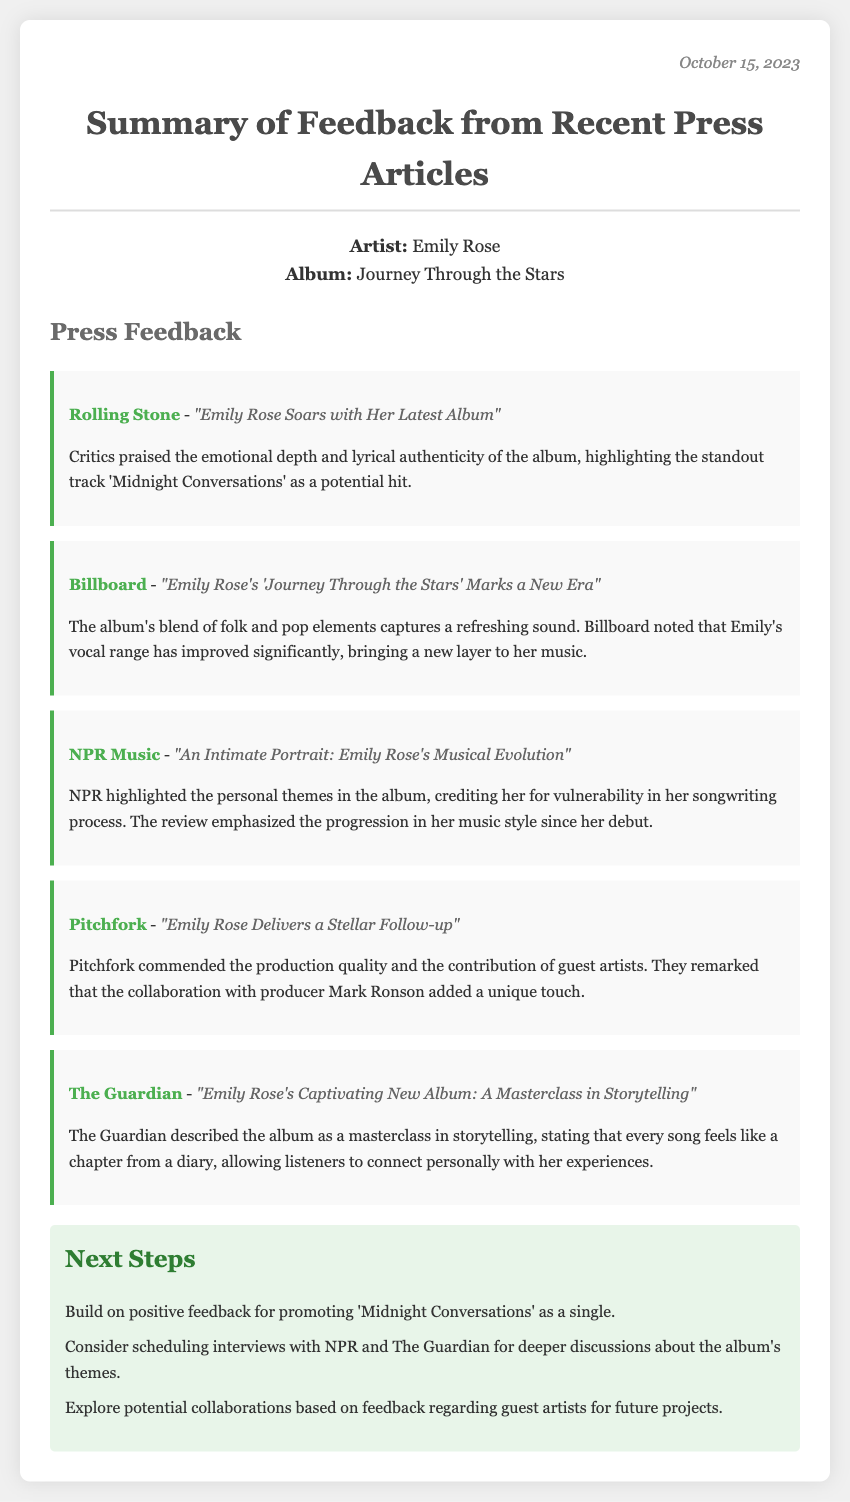What is the artist's name? The artist's name is mentioned in the album info section of the document.
Answer: Emily Rose What is the title of the album? The album title is stated right next to the artist's name in the album info section.
Answer: Journey Through the Stars Which publication praised the track 'Midnight Conversations'? This information is found in the feedback from Rolling Stone regarding their article about the album.
Answer: Rolling Stone What theme did NPR Music highlight about the album? The theme mentioned by NPR Music relates to her writing style and personal expression discussed in their review.
Answer: Vulnerability Who is the collaborator mentioned in the Pitchfork review? The collaborator is noted in the feedback from Pitchfork in regard to the production of the album.
Answer: Mark Ronson Which publication described the album as a masterclass in storytelling? The source of this opinion can be found in the feedback from The Guardian regarding their article on the album.
Answer: The Guardian What is one of the next steps mentioned for promoting the album? The next steps section lists specific actions regarding the album’s promotion.
Answer: Promote 'Midnight Conversations' as a single How did Billboard describe Emily's vocal range? This observation is found in the feedback section provided by Billboard.
Answer: Improved significantly 